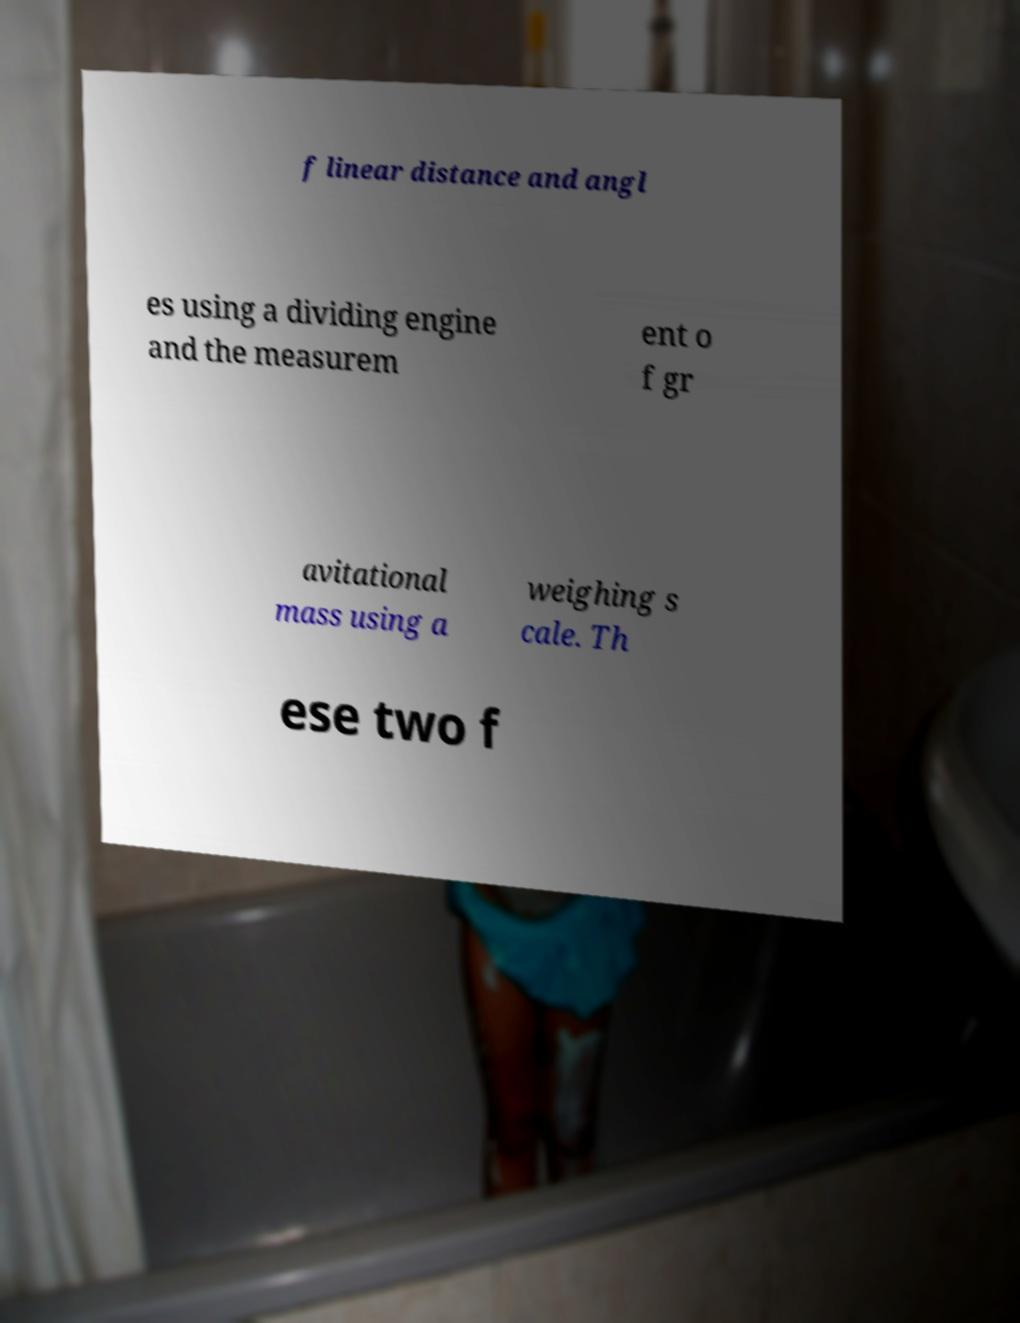Could you extract and type out the text from this image? f linear distance and angl es using a dividing engine and the measurem ent o f gr avitational mass using a weighing s cale. Th ese two f 